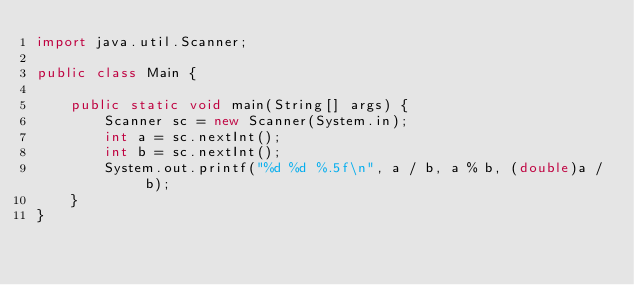Convert code to text. <code><loc_0><loc_0><loc_500><loc_500><_Java_>import java.util.Scanner;

public class Main {

	public static void main(String[] args) {
		Scanner sc = new Scanner(System.in);
		int a = sc.nextInt();
		int b = sc.nextInt();
		System.out.printf("%d %d %.5f\n", a / b, a % b, (double)a / b);
	}
}

</code> 